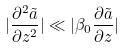Convert formula to latex. <formula><loc_0><loc_0><loc_500><loc_500>| \frac { \partial ^ { 2 } \tilde { a } } { \partial z ^ { 2 } } | \ll | \beta _ { 0 } \frac { \partial \tilde { a } } { \partial z } |</formula> 